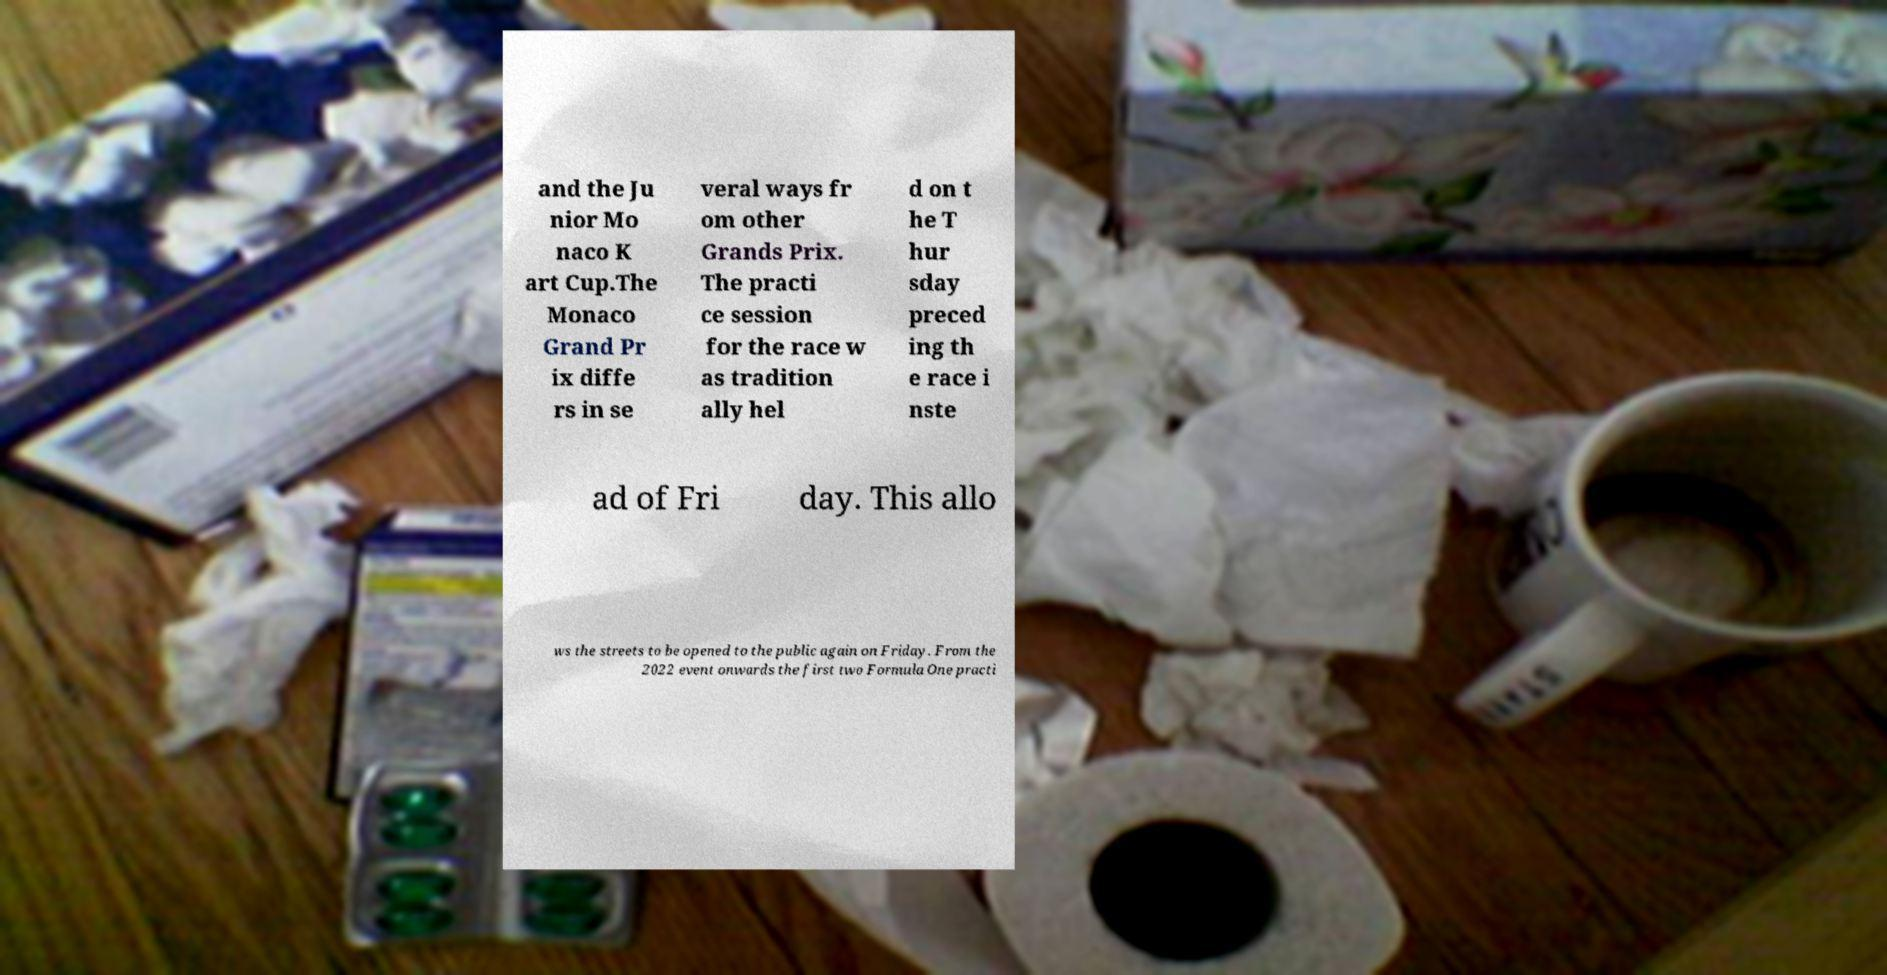Please read and relay the text visible in this image. What does it say? and the Ju nior Mo naco K art Cup.The Monaco Grand Pr ix diffe rs in se veral ways fr om other Grands Prix. The practi ce session for the race w as tradition ally hel d on t he T hur sday preced ing th e race i nste ad of Fri day. This allo ws the streets to be opened to the public again on Friday. From the 2022 event onwards the first two Formula One practi 